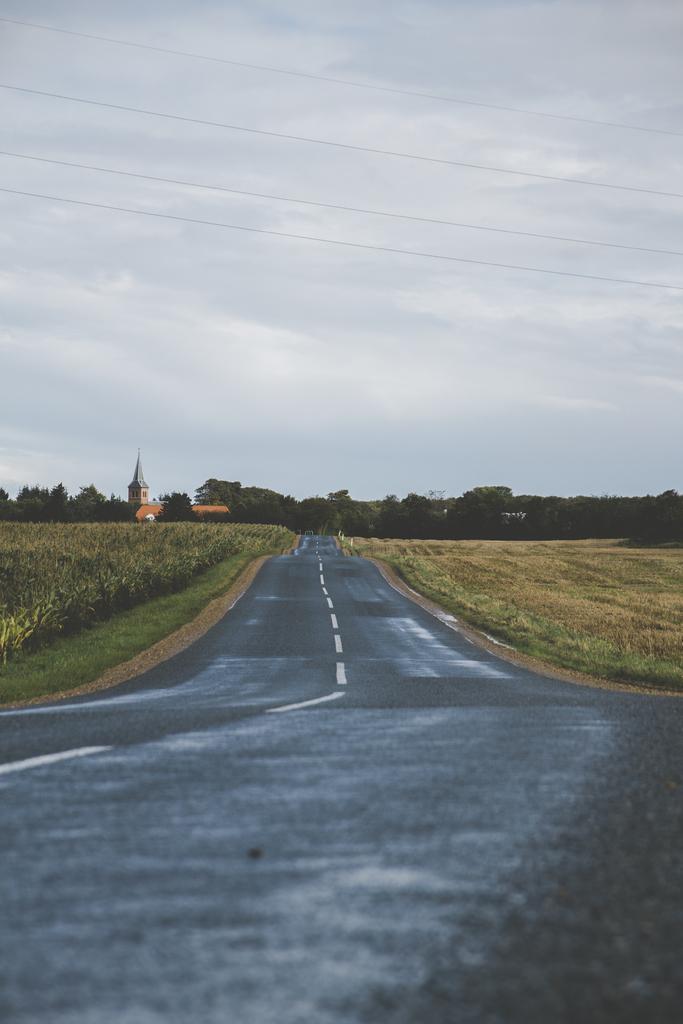Describe this image in one or two sentences. In the image there is a plain road, on the either side of the road there are crops and in the background there are plenty of trees, on the left side there are two houses. 